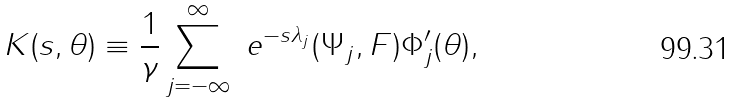<formula> <loc_0><loc_0><loc_500><loc_500>K ( s , \theta ) \equiv \frac { 1 } { \gamma } \sum _ { j = - \infty } ^ { \infty } \ e ^ { - s \lambda _ { j } } ( \Psi _ { j } , F ) \Phi _ { j } ^ { \prime } ( \theta ) ,</formula> 